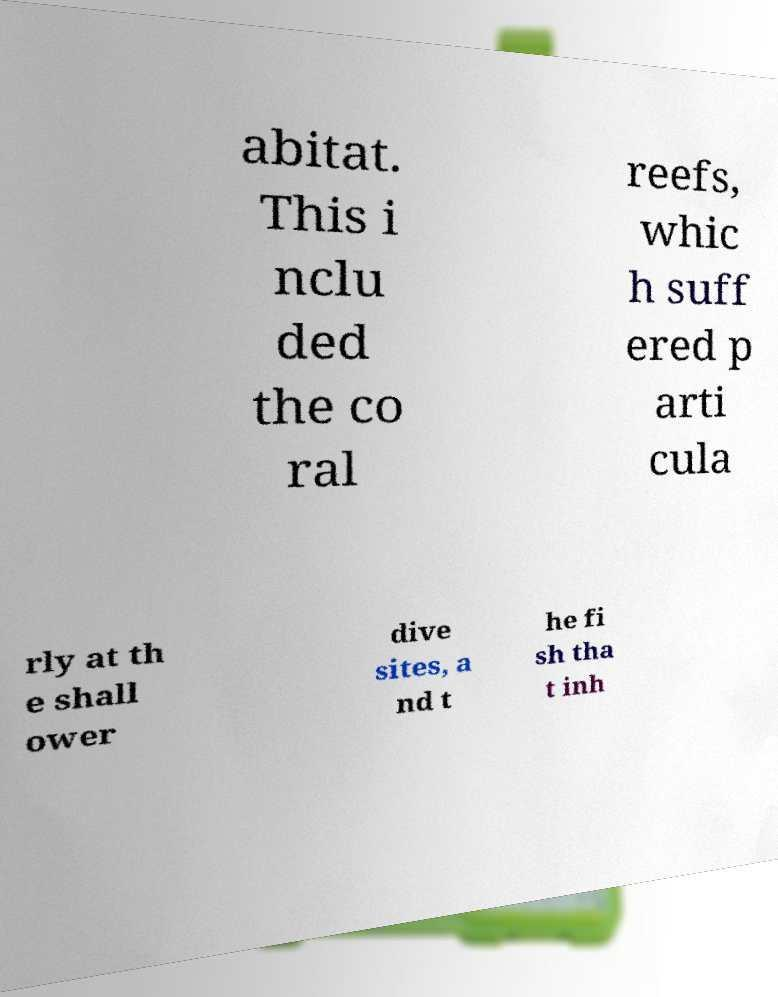Please read and relay the text visible in this image. What does it say? abitat. This i nclu ded the co ral reefs, whic h suff ered p arti cula rly at th e shall ower dive sites, a nd t he fi sh tha t inh 